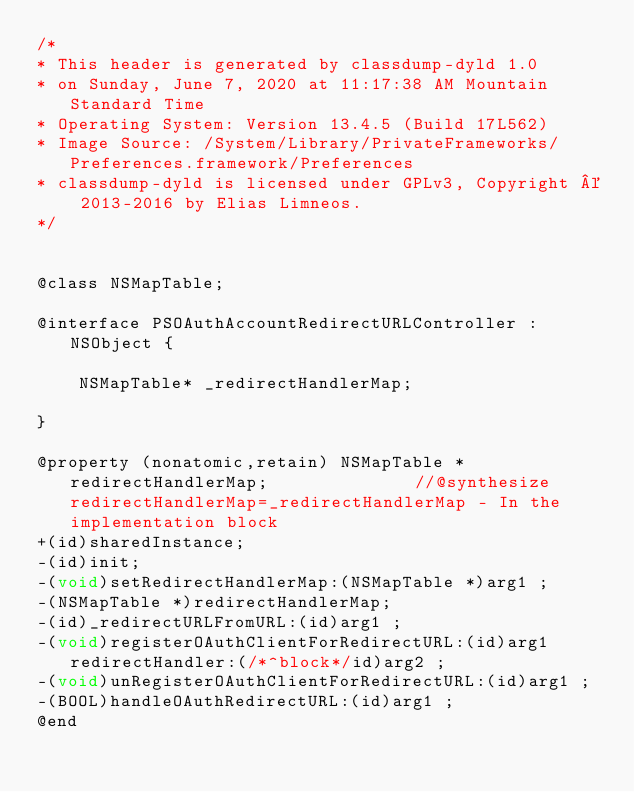Convert code to text. <code><loc_0><loc_0><loc_500><loc_500><_C_>/*
* This header is generated by classdump-dyld 1.0
* on Sunday, June 7, 2020 at 11:17:38 AM Mountain Standard Time
* Operating System: Version 13.4.5 (Build 17L562)
* Image Source: /System/Library/PrivateFrameworks/Preferences.framework/Preferences
* classdump-dyld is licensed under GPLv3, Copyright © 2013-2016 by Elias Limneos.
*/


@class NSMapTable;

@interface PSOAuthAccountRedirectURLController : NSObject {

	NSMapTable* _redirectHandlerMap;

}

@property (nonatomic,retain) NSMapTable * redirectHandlerMap;              //@synthesize redirectHandlerMap=_redirectHandlerMap - In the implementation block
+(id)sharedInstance;
-(id)init;
-(void)setRedirectHandlerMap:(NSMapTable *)arg1 ;
-(NSMapTable *)redirectHandlerMap;
-(id)_redirectURLFromURL:(id)arg1 ;
-(void)registerOAuthClientForRedirectURL:(id)arg1 redirectHandler:(/*^block*/id)arg2 ;
-(void)unRegisterOAuthClientForRedirectURL:(id)arg1 ;
-(BOOL)handleOAuthRedirectURL:(id)arg1 ;
@end

</code> 